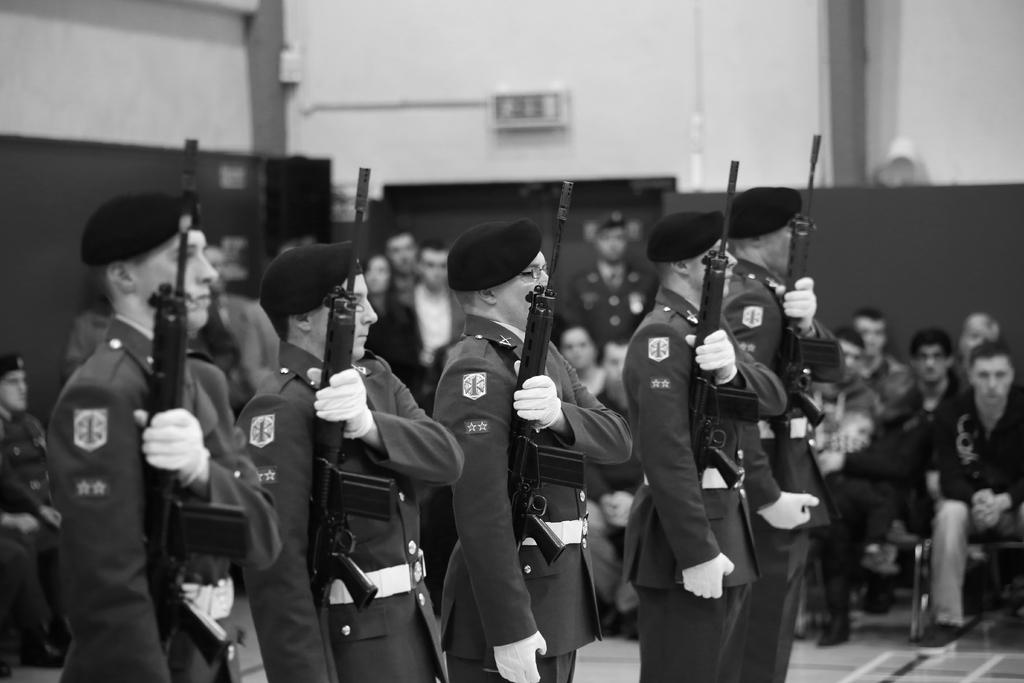What is the main subject of the image? The main subject of the image is a group of people. What are some of the people in the image doing? Some people are sitting, while others are standing. Are there any objects or items being held by the people in the image? Yes, some people are holding guns. What is the color scheme of the image? The image is in black and white. Can you see any boats in the image? No, there are no boats present in the image. Is your aunt in the image? There is no information about your aunt in the image or the provided facts, so it cannot be determined if she is present. 